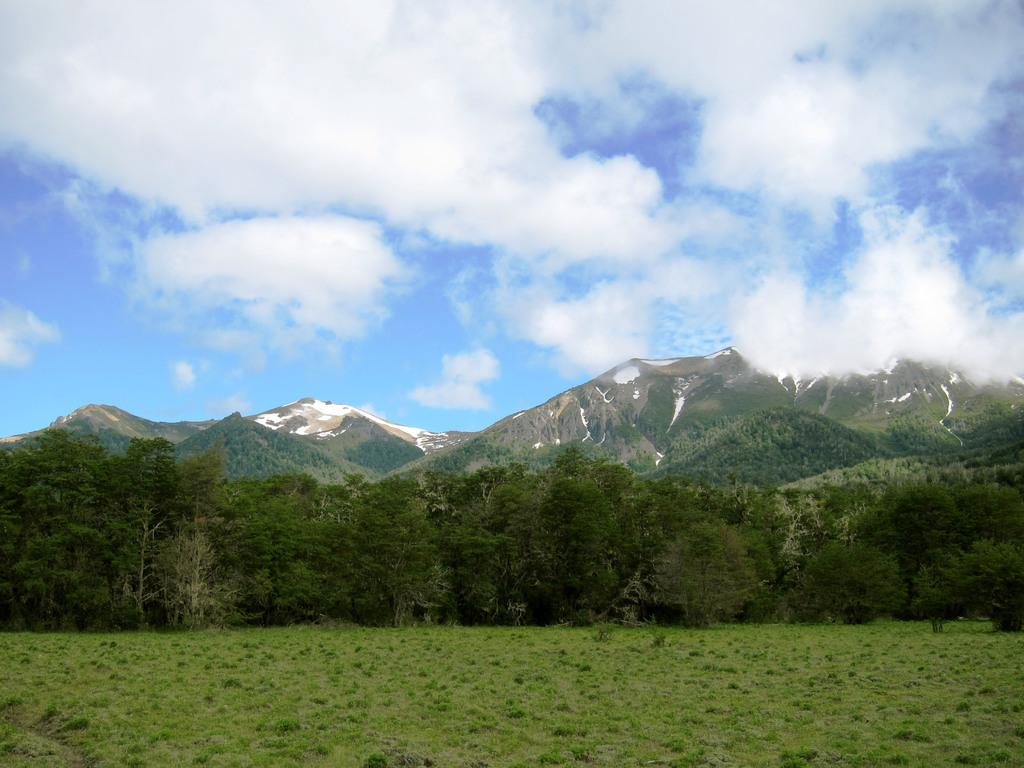What type of vegetation can be seen in the image? There is a group of trees in the image. What geographical feature is visible in the image? There are mountains visible in the image. What is the condition of the sky in the background of the image? The sky is cloudy in the background of the image. Where is the bomb located in the image? There is no bomb present in the image. What type of slope can be seen on the mountains in the image? The provided facts do not mention any specific slope on the mountains, so we cannot answer this question definitively. 